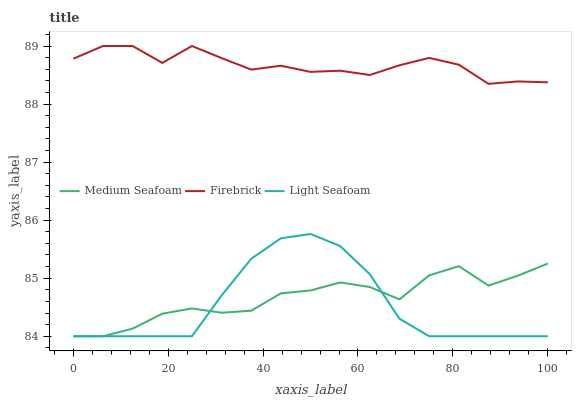Does Light Seafoam have the minimum area under the curve?
Answer yes or no. Yes. Does Firebrick have the maximum area under the curve?
Answer yes or no. Yes. Does Medium Seafoam have the minimum area under the curve?
Answer yes or no. No. Does Medium Seafoam have the maximum area under the curve?
Answer yes or no. No. Is Light Seafoam the smoothest?
Answer yes or no. Yes. Is Medium Seafoam the roughest?
Answer yes or no. Yes. Is Medium Seafoam the smoothest?
Answer yes or no. No. Is Light Seafoam the roughest?
Answer yes or no. No. Does Light Seafoam have the lowest value?
Answer yes or no. Yes. Does Firebrick have the highest value?
Answer yes or no. Yes. Does Light Seafoam have the highest value?
Answer yes or no. No. Is Light Seafoam less than Firebrick?
Answer yes or no. Yes. Is Firebrick greater than Light Seafoam?
Answer yes or no. Yes. Does Medium Seafoam intersect Light Seafoam?
Answer yes or no. Yes. Is Medium Seafoam less than Light Seafoam?
Answer yes or no. No. Is Medium Seafoam greater than Light Seafoam?
Answer yes or no. No. Does Light Seafoam intersect Firebrick?
Answer yes or no. No. 